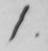What text is written in this handwritten line? 1 . 